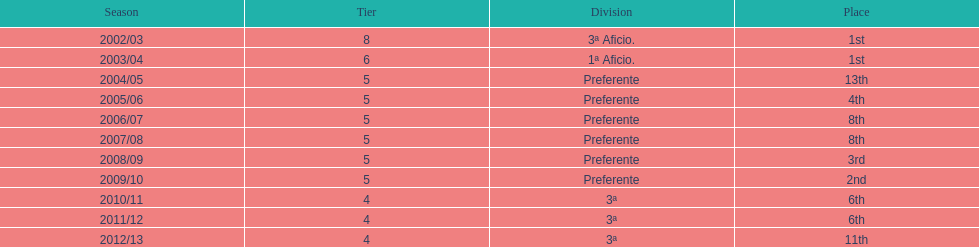How long has internacional de madrid cf been playing in the 3ª division? 3. 